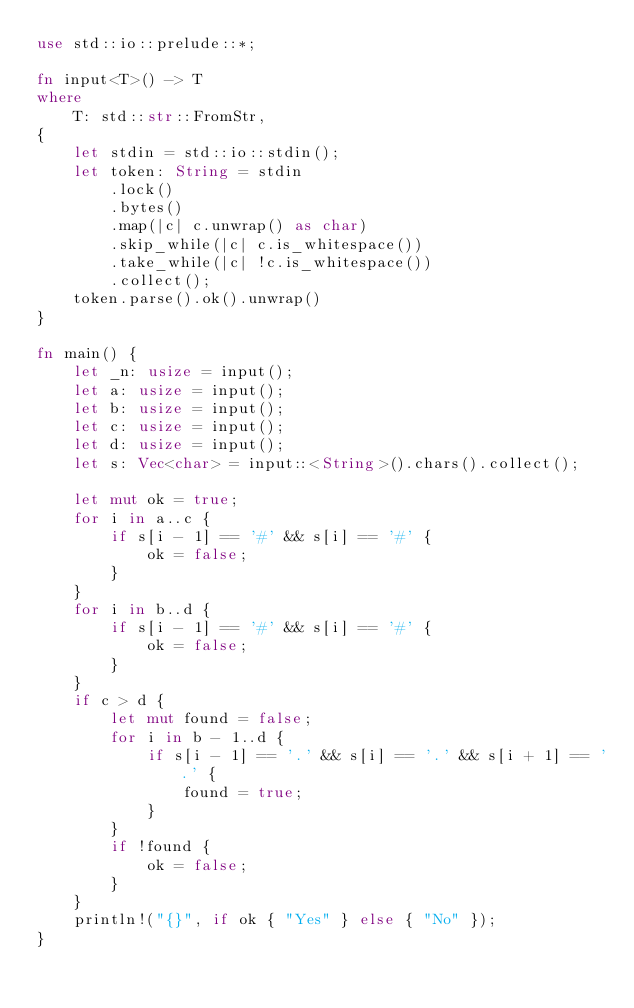Convert code to text. <code><loc_0><loc_0><loc_500><loc_500><_Rust_>use std::io::prelude::*;

fn input<T>() -> T
where
    T: std::str::FromStr,
{
    let stdin = std::io::stdin();
    let token: String = stdin
        .lock()
        .bytes()
        .map(|c| c.unwrap() as char)
        .skip_while(|c| c.is_whitespace())
        .take_while(|c| !c.is_whitespace())
        .collect();
    token.parse().ok().unwrap()
}

fn main() {
    let _n: usize = input();
    let a: usize = input();
    let b: usize = input();
    let c: usize = input();
    let d: usize = input();
    let s: Vec<char> = input::<String>().chars().collect();

    let mut ok = true;
    for i in a..c {
        if s[i - 1] == '#' && s[i] == '#' {
            ok = false;
        }
    }
    for i in b..d {
        if s[i - 1] == '#' && s[i] == '#' {
            ok = false;
        }
    }
    if c > d {
        let mut found = false;
        for i in b - 1..d {
            if s[i - 1] == '.' && s[i] == '.' && s[i + 1] == '.' {
                found = true;
            }
        }
        if !found {
            ok = false;
        }
    }
    println!("{}", if ok { "Yes" } else { "No" });
}
</code> 